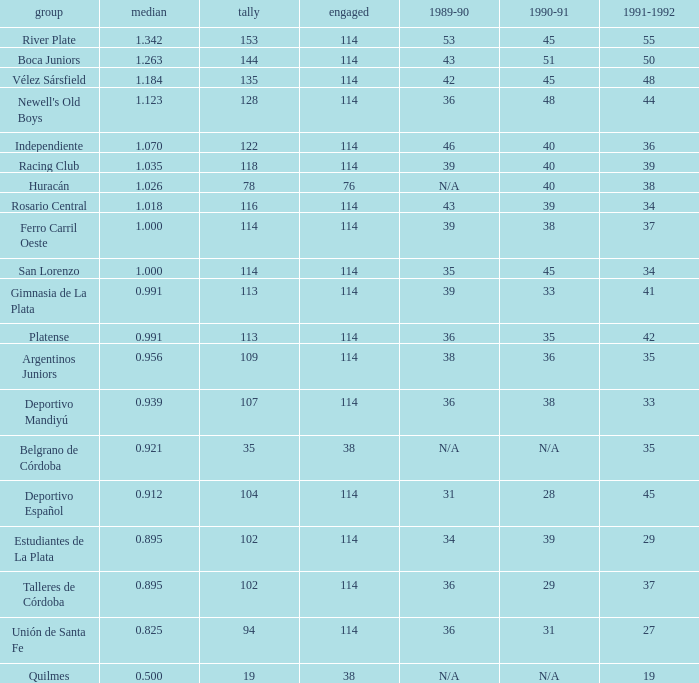How much Played has an Average smaller than 0.9390000000000001, and a 1990-91 of 28? 1.0. 